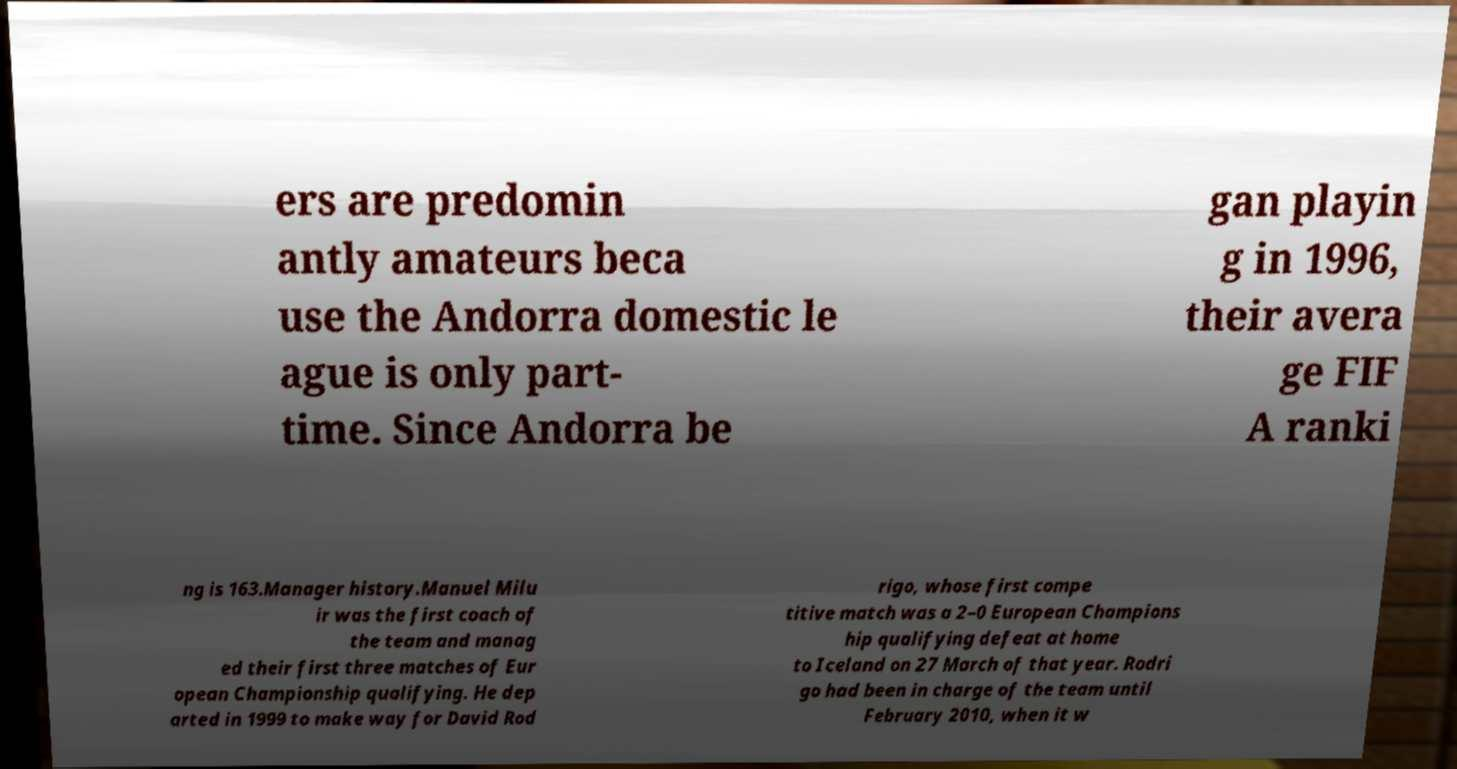Please identify and transcribe the text found in this image. ers are predomin antly amateurs beca use the Andorra domestic le ague is only part- time. Since Andorra be gan playin g in 1996, their avera ge FIF A ranki ng is 163.Manager history.Manuel Milu ir was the first coach of the team and manag ed their first three matches of Eur opean Championship qualifying. He dep arted in 1999 to make way for David Rod rigo, whose first compe titive match was a 2–0 European Champions hip qualifying defeat at home to Iceland on 27 March of that year. Rodri go had been in charge of the team until February 2010, when it w 